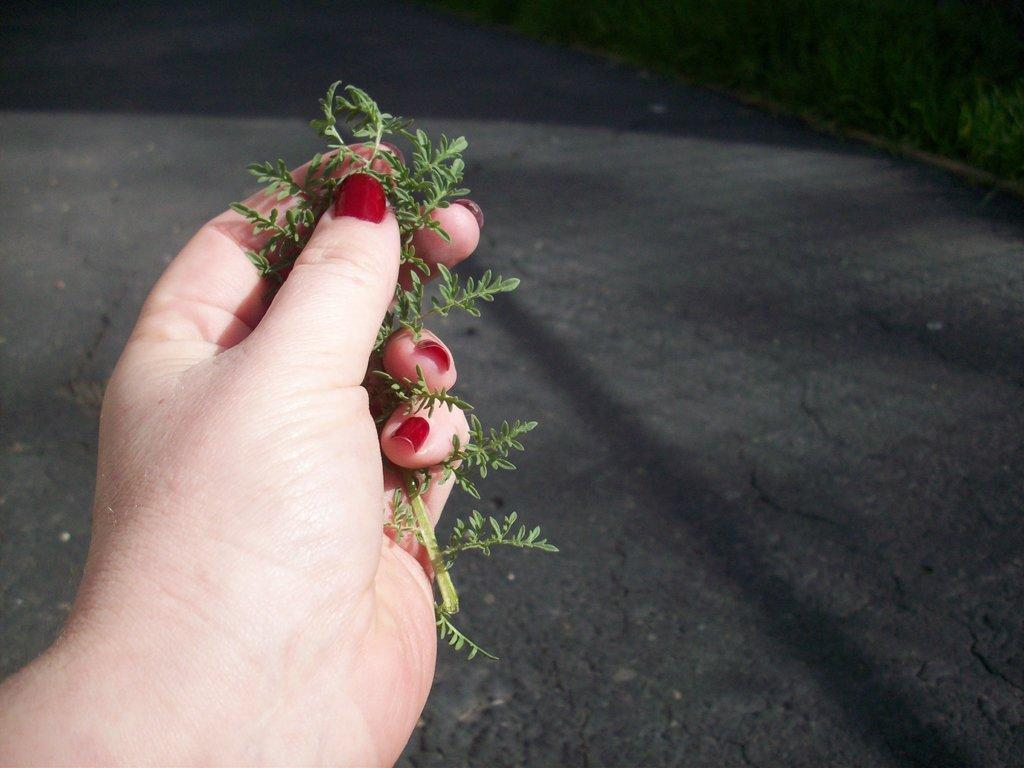What is the person holding in the image? The person is holding a plank with their hand. What can be seen in the foreground of the image? There is a road visible in the image. What type of vegetation is in the background of the image? There is grass in the background of the image. What type of beef is being served on the plank in the image? There is no beef present in the image; the person is holding a plank, not serving food. 